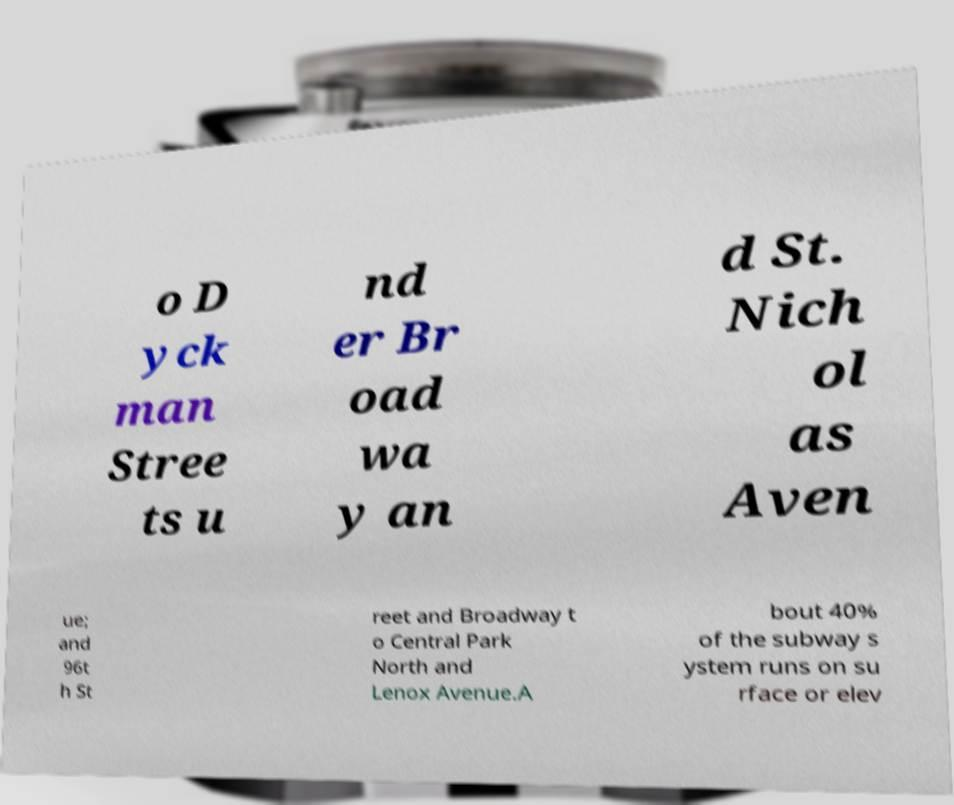Could you assist in decoding the text presented in this image and type it out clearly? o D yck man Stree ts u nd er Br oad wa y an d St. Nich ol as Aven ue; and 96t h St reet and Broadway t o Central Park North and Lenox Avenue.A bout 40% of the subway s ystem runs on su rface or elev 